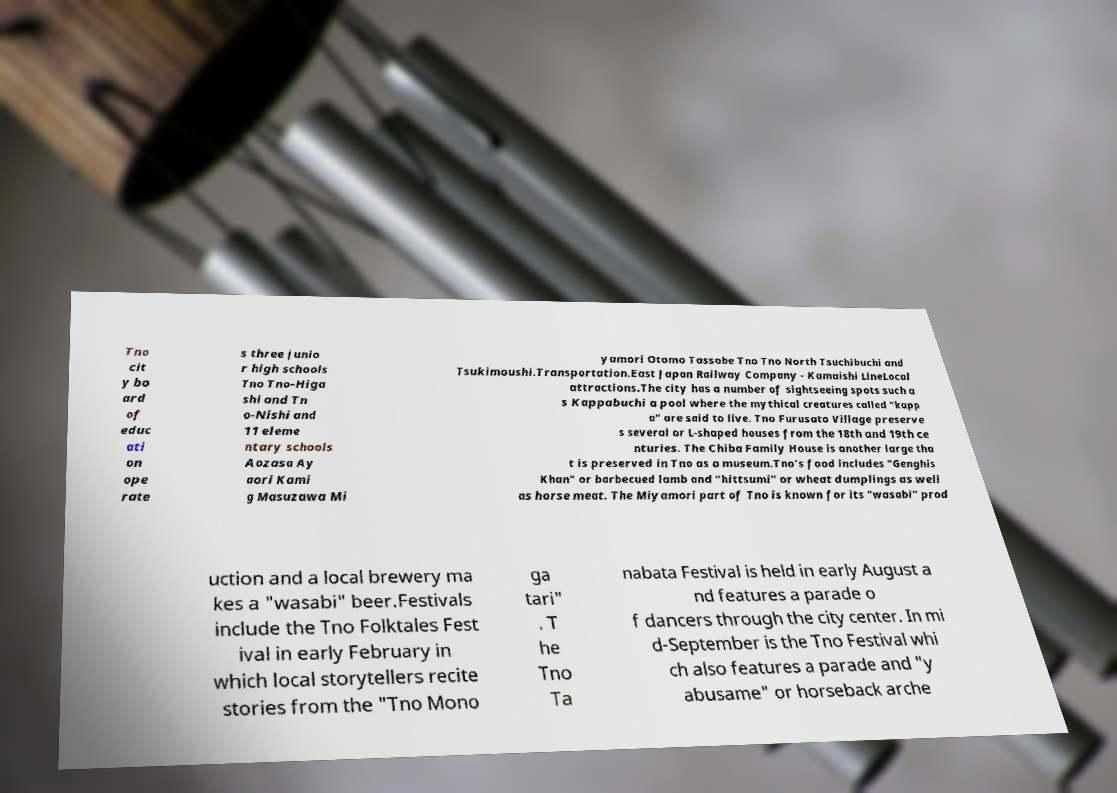Could you assist in decoding the text presented in this image and type it out clearly? Tno cit y bo ard of educ ati on ope rate s three junio r high schools Tno Tno-Higa shi and Tn o-Nishi and 11 eleme ntary schools Aozasa Ay aori Kami g Masuzawa Mi yamori Otomo Tassobe Tno Tno North Tsuchibuchi and Tsukimoushi.Transportation.East Japan Railway Company - Kamaishi LineLocal attractions.The city has a number of sightseeing spots such a s Kappabuchi a pool where the mythical creatures called "kapp a" are said to live. Tno Furusato Village preserve s several or L-shaped houses from the 18th and 19th ce nturies. The Chiba Family House is another large tha t is preserved in Tno as a museum.Tno's food includes "Genghis Khan" or barbecued lamb and "hittsumi" or wheat dumplings as well as horse meat. The Miyamori part of Tno is known for its "wasabi" prod uction and a local brewery ma kes a "wasabi" beer.Festivals include the Tno Folktales Fest ival in early February in which local storytellers recite stories from the "Tno Mono ga tari" . T he Tno Ta nabata Festival is held in early August a nd features a parade o f dancers through the city center. In mi d-September is the Tno Festival whi ch also features a parade and "y abusame" or horseback arche 